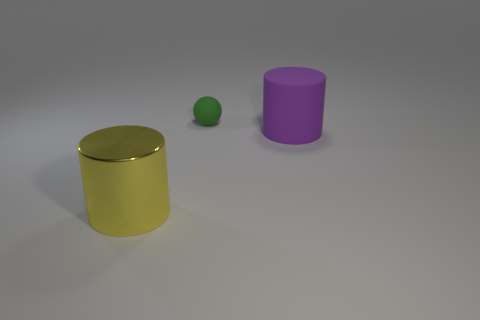What is the shape of the purple thing that is the same material as the small green thing?
Your response must be concise. Cylinder. How big is the cylinder that is to the right of the metal cylinder?
Provide a succinct answer. Large. The matte thing that is the same size as the metal cylinder is what shape?
Ensure brevity in your answer.  Cylinder. Does the big cylinder in front of the large purple object have the same material as the object that is behind the purple object?
Ensure brevity in your answer.  No. The large thing that is to the left of the green sphere behind the large purple cylinder is made of what material?
Offer a very short reply. Metal. There is a cylinder that is on the left side of the cylinder that is behind the object in front of the purple matte cylinder; what is its size?
Provide a succinct answer. Large. Do the ball and the matte cylinder have the same size?
Provide a succinct answer. No. There is a big thing that is on the right side of the large shiny object; is it the same shape as the large object that is on the left side of the tiny matte ball?
Provide a succinct answer. Yes. Is there a big rubber object to the right of the matte thing that is right of the green object?
Your answer should be compact. No. Is there a large purple cylinder?
Give a very brief answer. Yes. 